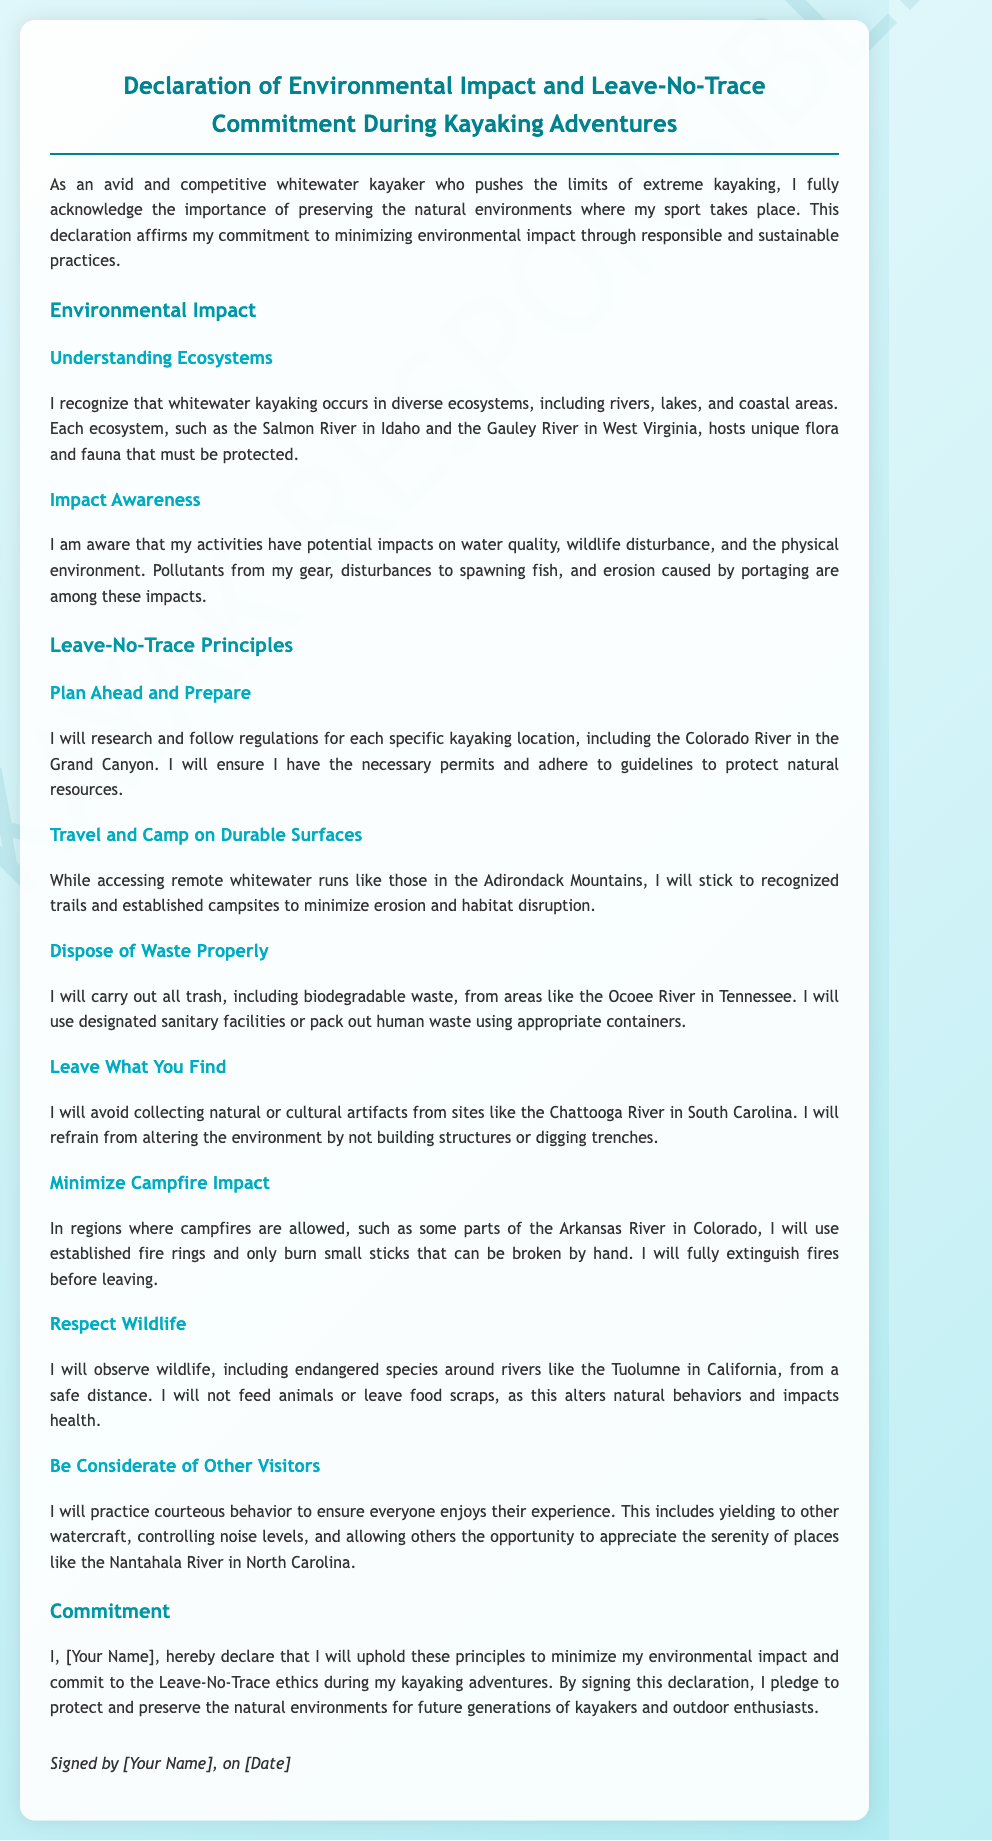What is the title of the document? The title is stated at the top of the document and outlines the main subject of the declaration.
Answer: Declaration of Environmental Impact and Leave-No-Trace Commitment During Kayaking Adventures Who signed the declaration? The document includes a space for a personal name, indicating the individual who has signed it.
Answer: [Your Name] What is one area mentioned in the document where kayaking occurs? The document references specific rivers and ecosystems related to kayaking, providing examples for understanding environmental impact.
Answer: Salmon River What principle is related to minimizing campfire impact? The declaration outlines specific principles to adhere to during kayaking, including actions to take with campfires.
Answer: Minimize Campfire Impact Which river is associated with the commitment to carry out all trash? The document lists rivers in connection with the Leave-No-Trace principles, specifically noting how to properly dispose of waste.
Answer: Ocoee River What does the declaration emphasize about wildlife? The text highlights the need to respect and observe wildlife responsibly, ensuring minimal disruption.
Answer: Respect Wildlife What is the overarching theme of this document? The document's main objective is clearly stated in the introduction and throughout various sections, focusing on environmental conservation and responsibility.
Answer: Environmental Impact What is the date format mentioned for signing the declaration? The document includes a placeholder for the date to signify when the declaration is signed.
Answer: [Date] 